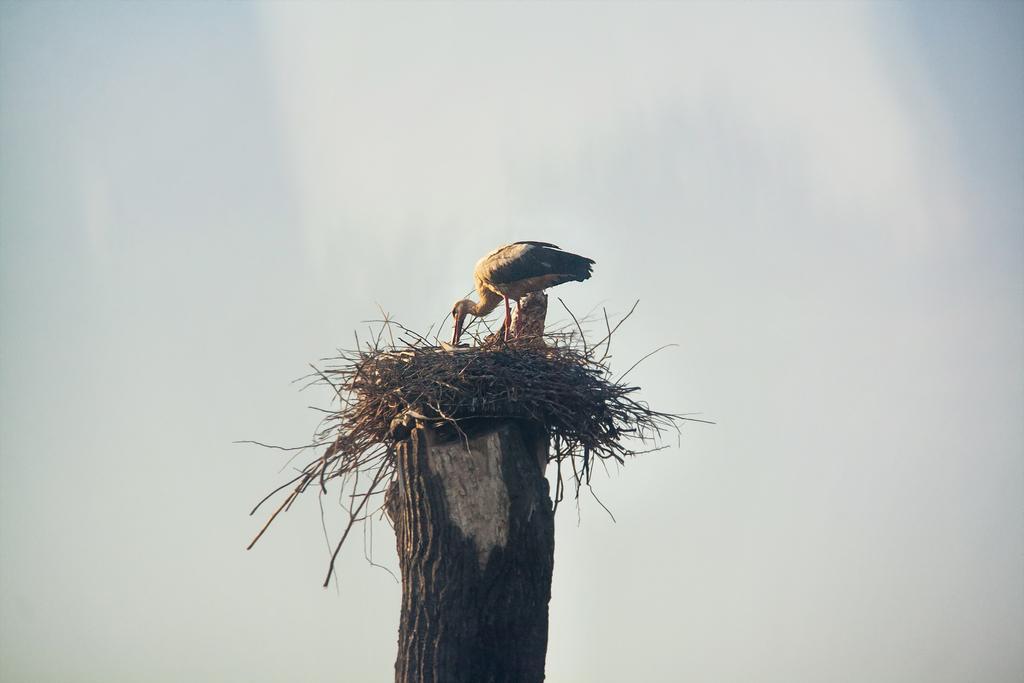Can you describe this image briefly? In this picture we can see a bird and the nest. This nest is visible on the wooden object. We can see the sky in the background. 